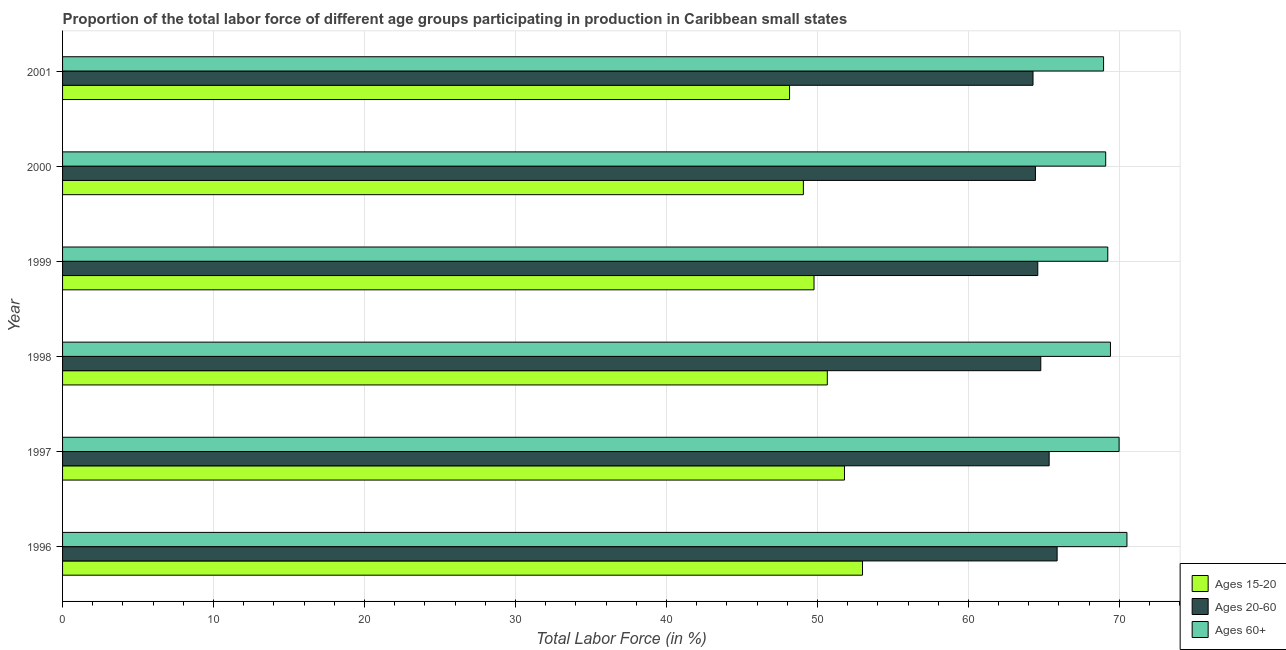How many groups of bars are there?
Give a very brief answer. 6. Are the number of bars per tick equal to the number of legend labels?
Your answer should be compact. Yes. How many bars are there on the 3rd tick from the top?
Your answer should be very brief. 3. What is the label of the 4th group of bars from the top?
Your answer should be very brief. 1998. What is the percentage of labor force within the age group 15-20 in 1997?
Make the answer very short. 51.79. Across all years, what is the maximum percentage of labor force within the age group 20-60?
Your response must be concise. 65.88. Across all years, what is the minimum percentage of labor force above age 60?
Keep it short and to the point. 68.95. In which year was the percentage of labor force within the age group 20-60 minimum?
Ensure brevity in your answer.  2001. What is the total percentage of labor force above age 60 in the graph?
Make the answer very short. 417.18. What is the difference between the percentage of labor force within the age group 15-20 in 1996 and that in 1999?
Your response must be concise. 3.21. What is the difference between the percentage of labor force within the age group 20-60 in 1996 and the percentage of labor force within the age group 15-20 in 1999?
Ensure brevity in your answer.  16.1. What is the average percentage of labor force above age 60 per year?
Offer a terse response. 69.53. In the year 1996, what is the difference between the percentage of labor force within the age group 20-60 and percentage of labor force within the age group 15-20?
Your answer should be very brief. 12.89. What is the ratio of the percentage of labor force above age 60 in 1998 to that in 2000?
Provide a succinct answer. 1. What is the difference between the highest and the second highest percentage of labor force above age 60?
Ensure brevity in your answer.  0.52. What is the difference between the highest and the lowest percentage of labor force within the age group 20-60?
Keep it short and to the point. 1.6. In how many years, is the percentage of labor force above age 60 greater than the average percentage of labor force above age 60 taken over all years?
Provide a short and direct response. 2. What does the 2nd bar from the top in 2000 represents?
Your answer should be very brief. Ages 20-60. What does the 2nd bar from the bottom in 1999 represents?
Offer a terse response. Ages 20-60. How many bars are there?
Provide a succinct answer. 18. How many years are there in the graph?
Your answer should be compact. 6. Are the values on the major ticks of X-axis written in scientific E-notation?
Your response must be concise. No. Where does the legend appear in the graph?
Your answer should be compact. Bottom right. What is the title of the graph?
Your response must be concise. Proportion of the total labor force of different age groups participating in production in Caribbean small states. What is the label or title of the Y-axis?
Provide a succinct answer. Year. What is the Total Labor Force (in %) of Ages 15-20 in 1996?
Provide a succinct answer. 52.99. What is the Total Labor Force (in %) of Ages 20-60 in 1996?
Provide a short and direct response. 65.88. What is the Total Labor Force (in %) in Ages 60+ in 1996?
Make the answer very short. 70.5. What is the Total Labor Force (in %) in Ages 15-20 in 1997?
Offer a terse response. 51.79. What is the Total Labor Force (in %) of Ages 20-60 in 1997?
Offer a terse response. 65.35. What is the Total Labor Force (in %) in Ages 60+ in 1997?
Ensure brevity in your answer.  69.98. What is the Total Labor Force (in %) in Ages 15-20 in 1998?
Keep it short and to the point. 50.66. What is the Total Labor Force (in %) of Ages 20-60 in 1998?
Ensure brevity in your answer.  64.79. What is the Total Labor Force (in %) in Ages 60+ in 1998?
Ensure brevity in your answer.  69.41. What is the Total Labor Force (in %) in Ages 15-20 in 1999?
Keep it short and to the point. 49.77. What is the Total Labor Force (in %) of Ages 20-60 in 1999?
Your answer should be compact. 64.6. What is the Total Labor Force (in %) in Ages 60+ in 1999?
Provide a short and direct response. 69.23. What is the Total Labor Force (in %) in Ages 15-20 in 2000?
Your response must be concise. 49.07. What is the Total Labor Force (in %) of Ages 20-60 in 2000?
Your response must be concise. 64.44. What is the Total Labor Force (in %) of Ages 60+ in 2000?
Offer a terse response. 69.1. What is the Total Labor Force (in %) of Ages 15-20 in 2001?
Ensure brevity in your answer.  48.16. What is the Total Labor Force (in %) of Ages 20-60 in 2001?
Provide a succinct answer. 64.28. What is the Total Labor Force (in %) in Ages 60+ in 2001?
Your answer should be very brief. 68.95. Across all years, what is the maximum Total Labor Force (in %) of Ages 15-20?
Your answer should be very brief. 52.99. Across all years, what is the maximum Total Labor Force (in %) in Ages 20-60?
Your response must be concise. 65.88. Across all years, what is the maximum Total Labor Force (in %) of Ages 60+?
Your response must be concise. 70.5. Across all years, what is the minimum Total Labor Force (in %) in Ages 15-20?
Your response must be concise. 48.16. Across all years, what is the minimum Total Labor Force (in %) of Ages 20-60?
Offer a terse response. 64.28. Across all years, what is the minimum Total Labor Force (in %) of Ages 60+?
Offer a terse response. 68.95. What is the total Total Labor Force (in %) in Ages 15-20 in the graph?
Give a very brief answer. 302.43. What is the total Total Labor Force (in %) of Ages 20-60 in the graph?
Provide a short and direct response. 389.34. What is the total Total Labor Force (in %) of Ages 60+ in the graph?
Keep it short and to the point. 417.18. What is the difference between the Total Labor Force (in %) in Ages 15-20 in 1996 and that in 1997?
Make the answer very short. 1.2. What is the difference between the Total Labor Force (in %) in Ages 20-60 in 1996 and that in 1997?
Make the answer very short. 0.53. What is the difference between the Total Labor Force (in %) in Ages 60+ in 1996 and that in 1997?
Offer a terse response. 0.52. What is the difference between the Total Labor Force (in %) of Ages 15-20 in 1996 and that in 1998?
Make the answer very short. 2.33. What is the difference between the Total Labor Force (in %) in Ages 20-60 in 1996 and that in 1998?
Keep it short and to the point. 1.08. What is the difference between the Total Labor Force (in %) of Ages 60+ in 1996 and that in 1998?
Offer a very short reply. 1.09. What is the difference between the Total Labor Force (in %) in Ages 15-20 in 1996 and that in 1999?
Give a very brief answer. 3.21. What is the difference between the Total Labor Force (in %) of Ages 20-60 in 1996 and that in 1999?
Your response must be concise. 1.28. What is the difference between the Total Labor Force (in %) in Ages 60+ in 1996 and that in 1999?
Give a very brief answer. 1.27. What is the difference between the Total Labor Force (in %) in Ages 15-20 in 1996 and that in 2000?
Provide a succinct answer. 3.92. What is the difference between the Total Labor Force (in %) in Ages 20-60 in 1996 and that in 2000?
Provide a short and direct response. 1.44. What is the difference between the Total Labor Force (in %) in Ages 60+ in 1996 and that in 2000?
Make the answer very short. 1.41. What is the difference between the Total Labor Force (in %) of Ages 15-20 in 1996 and that in 2001?
Give a very brief answer. 4.83. What is the difference between the Total Labor Force (in %) of Ages 20-60 in 1996 and that in 2001?
Ensure brevity in your answer.  1.6. What is the difference between the Total Labor Force (in %) in Ages 60+ in 1996 and that in 2001?
Offer a very short reply. 1.55. What is the difference between the Total Labor Force (in %) of Ages 15-20 in 1997 and that in 1998?
Offer a terse response. 1.14. What is the difference between the Total Labor Force (in %) of Ages 20-60 in 1997 and that in 1998?
Keep it short and to the point. 0.55. What is the difference between the Total Labor Force (in %) in Ages 60+ in 1997 and that in 1998?
Make the answer very short. 0.57. What is the difference between the Total Labor Force (in %) in Ages 15-20 in 1997 and that in 1999?
Ensure brevity in your answer.  2.02. What is the difference between the Total Labor Force (in %) of Ages 20-60 in 1997 and that in 1999?
Provide a short and direct response. 0.75. What is the difference between the Total Labor Force (in %) in Ages 60+ in 1997 and that in 1999?
Make the answer very short. 0.75. What is the difference between the Total Labor Force (in %) in Ages 15-20 in 1997 and that in 2000?
Make the answer very short. 2.72. What is the difference between the Total Labor Force (in %) in Ages 20-60 in 1997 and that in 2000?
Your response must be concise. 0.91. What is the difference between the Total Labor Force (in %) of Ages 60+ in 1997 and that in 2000?
Offer a very short reply. 0.89. What is the difference between the Total Labor Force (in %) in Ages 15-20 in 1997 and that in 2001?
Provide a short and direct response. 3.64. What is the difference between the Total Labor Force (in %) in Ages 20-60 in 1997 and that in 2001?
Provide a short and direct response. 1.07. What is the difference between the Total Labor Force (in %) of Ages 60+ in 1997 and that in 2001?
Your answer should be very brief. 1.03. What is the difference between the Total Labor Force (in %) of Ages 15-20 in 1998 and that in 1999?
Offer a terse response. 0.88. What is the difference between the Total Labor Force (in %) of Ages 20-60 in 1998 and that in 1999?
Your answer should be very brief. 0.2. What is the difference between the Total Labor Force (in %) of Ages 60+ in 1998 and that in 1999?
Your response must be concise. 0.18. What is the difference between the Total Labor Force (in %) of Ages 15-20 in 1998 and that in 2000?
Make the answer very short. 1.59. What is the difference between the Total Labor Force (in %) of Ages 20-60 in 1998 and that in 2000?
Give a very brief answer. 0.35. What is the difference between the Total Labor Force (in %) of Ages 60+ in 1998 and that in 2000?
Make the answer very short. 0.32. What is the difference between the Total Labor Force (in %) of Ages 15-20 in 1998 and that in 2001?
Your answer should be very brief. 2.5. What is the difference between the Total Labor Force (in %) of Ages 20-60 in 1998 and that in 2001?
Keep it short and to the point. 0.51. What is the difference between the Total Labor Force (in %) of Ages 60+ in 1998 and that in 2001?
Your answer should be very brief. 0.46. What is the difference between the Total Labor Force (in %) of Ages 15-20 in 1999 and that in 2000?
Your answer should be compact. 0.71. What is the difference between the Total Labor Force (in %) in Ages 20-60 in 1999 and that in 2000?
Your answer should be compact. 0.16. What is the difference between the Total Labor Force (in %) in Ages 60+ in 1999 and that in 2000?
Your answer should be very brief. 0.14. What is the difference between the Total Labor Force (in %) of Ages 15-20 in 1999 and that in 2001?
Your answer should be very brief. 1.62. What is the difference between the Total Labor Force (in %) in Ages 20-60 in 1999 and that in 2001?
Offer a very short reply. 0.32. What is the difference between the Total Labor Force (in %) of Ages 60+ in 1999 and that in 2001?
Your answer should be very brief. 0.28. What is the difference between the Total Labor Force (in %) of Ages 15-20 in 2000 and that in 2001?
Give a very brief answer. 0.91. What is the difference between the Total Labor Force (in %) in Ages 20-60 in 2000 and that in 2001?
Provide a succinct answer. 0.16. What is the difference between the Total Labor Force (in %) of Ages 60+ in 2000 and that in 2001?
Keep it short and to the point. 0.14. What is the difference between the Total Labor Force (in %) in Ages 15-20 in 1996 and the Total Labor Force (in %) in Ages 20-60 in 1997?
Your answer should be compact. -12.36. What is the difference between the Total Labor Force (in %) of Ages 15-20 in 1996 and the Total Labor Force (in %) of Ages 60+ in 1997?
Provide a succinct answer. -17. What is the difference between the Total Labor Force (in %) of Ages 20-60 in 1996 and the Total Labor Force (in %) of Ages 60+ in 1997?
Ensure brevity in your answer.  -4.11. What is the difference between the Total Labor Force (in %) of Ages 15-20 in 1996 and the Total Labor Force (in %) of Ages 20-60 in 1998?
Your answer should be compact. -11.81. What is the difference between the Total Labor Force (in %) of Ages 15-20 in 1996 and the Total Labor Force (in %) of Ages 60+ in 1998?
Offer a terse response. -16.42. What is the difference between the Total Labor Force (in %) of Ages 20-60 in 1996 and the Total Labor Force (in %) of Ages 60+ in 1998?
Give a very brief answer. -3.53. What is the difference between the Total Labor Force (in %) in Ages 15-20 in 1996 and the Total Labor Force (in %) in Ages 20-60 in 1999?
Your answer should be compact. -11.61. What is the difference between the Total Labor Force (in %) of Ages 15-20 in 1996 and the Total Labor Force (in %) of Ages 60+ in 1999?
Your answer should be compact. -16.25. What is the difference between the Total Labor Force (in %) in Ages 20-60 in 1996 and the Total Labor Force (in %) in Ages 60+ in 1999?
Give a very brief answer. -3.36. What is the difference between the Total Labor Force (in %) of Ages 15-20 in 1996 and the Total Labor Force (in %) of Ages 20-60 in 2000?
Offer a terse response. -11.45. What is the difference between the Total Labor Force (in %) of Ages 15-20 in 1996 and the Total Labor Force (in %) of Ages 60+ in 2000?
Offer a very short reply. -16.11. What is the difference between the Total Labor Force (in %) of Ages 20-60 in 1996 and the Total Labor Force (in %) of Ages 60+ in 2000?
Provide a short and direct response. -3.22. What is the difference between the Total Labor Force (in %) of Ages 15-20 in 1996 and the Total Labor Force (in %) of Ages 20-60 in 2001?
Offer a very short reply. -11.29. What is the difference between the Total Labor Force (in %) in Ages 15-20 in 1996 and the Total Labor Force (in %) in Ages 60+ in 2001?
Provide a succinct answer. -15.97. What is the difference between the Total Labor Force (in %) of Ages 20-60 in 1996 and the Total Labor Force (in %) of Ages 60+ in 2001?
Provide a succinct answer. -3.08. What is the difference between the Total Labor Force (in %) of Ages 15-20 in 1997 and the Total Labor Force (in %) of Ages 20-60 in 1998?
Your answer should be compact. -13. What is the difference between the Total Labor Force (in %) in Ages 15-20 in 1997 and the Total Labor Force (in %) in Ages 60+ in 1998?
Your answer should be compact. -17.62. What is the difference between the Total Labor Force (in %) in Ages 20-60 in 1997 and the Total Labor Force (in %) in Ages 60+ in 1998?
Give a very brief answer. -4.06. What is the difference between the Total Labor Force (in %) of Ages 15-20 in 1997 and the Total Labor Force (in %) of Ages 20-60 in 1999?
Give a very brief answer. -12.8. What is the difference between the Total Labor Force (in %) of Ages 15-20 in 1997 and the Total Labor Force (in %) of Ages 60+ in 1999?
Offer a terse response. -17.44. What is the difference between the Total Labor Force (in %) in Ages 20-60 in 1997 and the Total Labor Force (in %) in Ages 60+ in 1999?
Offer a very short reply. -3.88. What is the difference between the Total Labor Force (in %) in Ages 15-20 in 1997 and the Total Labor Force (in %) in Ages 20-60 in 2000?
Offer a terse response. -12.65. What is the difference between the Total Labor Force (in %) of Ages 15-20 in 1997 and the Total Labor Force (in %) of Ages 60+ in 2000?
Offer a very short reply. -17.3. What is the difference between the Total Labor Force (in %) of Ages 20-60 in 1997 and the Total Labor Force (in %) of Ages 60+ in 2000?
Your response must be concise. -3.75. What is the difference between the Total Labor Force (in %) in Ages 15-20 in 1997 and the Total Labor Force (in %) in Ages 20-60 in 2001?
Keep it short and to the point. -12.49. What is the difference between the Total Labor Force (in %) of Ages 15-20 in 1997 and the Total Labor Force (in %) of Ages 60+ in 2001?
Provide a succinct answer. -17.16. What is the difference between the Total Labor Force (in %) of Ages 20-60 in 1997 and the Total Labor Force (in %) of Ages 60+ in 2001?
Keep it short and to the point. -3.61. What is the difference between the Total Labor Force (in %) in Ages 15-20 in 1998 and the Total Labor Force (in %) in Ages 20-60 in 1999?
Offer a terse response. -13.94. What is the difference between the Total Labor Force (in %) in Ages 15-20 in 1998 and the Total Labor Force (in %) in Ages 60+ in 1999?
Provide a succinct answer. -18.58. What is the difference between the Total Labor Force (in %) in Ages 20-60 in 1998 and the Total Labor Force (in %) in Ages 60+ in 1999?
Your response must be concise. -4.44. What is the difference between the Total Labor Force (in %) in Ages 15-20 in 1998 and the Total Labor Force (in %) in Ages 20-60 in 2000?
Provide a succinct answer. -13.79. What is the difference between the Total Labor Force (in %) in Ages 15-20 in 1998 and the Total Labor Force (in %) in Ages 60+ in 2000?
Make the answer very short. -18.44. What is the difference between the Total Labor Force (in %) in Ages 20-60 in 1998 and the Total Labor Force (in %) in Ages 60+ in 2000?
Provide a short and direct response. -4.3. What is the difference between the Total Labor Force (in %) in Ages 15-20 in 1998 and the Total Labor Force (in %) in Ages 20-60 in 2001?
Ensure brevity in your answer.  -13.63. What is the difference between the Total Labor Force (in %) of Ages 15-20 in 1998 and the Total Labor Force (in %) of Ages 60+ in 2001?
Make the answer very short. -18.3. What is the difference between the Total Labor Force (in %) in Ages 20-60 in 1998 and the Total Labor Force (in %) in Ages 60+ in 2001?
Provide a succinct answer. -4.16. What is the difference between the Total Labor Force (in %) in Ages 15-20 in 1999 and the Total Labor Force (in %) in Ages 20-60 in 2000?
Offer a terse response. -14.67. What is the difference between the Total Labor Force (in %) in Ages 15-20 in 1999 and the Total Labor Force (in %) in Ages 60+ in 2000?
Provide a short and direct response. -19.32. What is the difference between the Total Labor Force (in %) in Ages 20-60 in 1999 and the Total Labor Force (in %) in Ages 60+ in 2000?
Your answer should be compact. -4.5. What is the difference between the Total Labor Force (in %) in Ages 15-20 in 1999 and the Total Labor Force (in %) in Ages 20-60 in 2001?
Your response must be concise. -14.51. What is the difference between the Total Labor Force (in %) in Ages 15-20 in 1999 and the Total Labor Force (in %) in Ages 60+ in 2001?
Provide a short and direct response. -19.18. What is the difference between the Total Labor Force (in %) in Ages 20-60 in 1999 and the Total Labor Force (in %) in Ages 60+ in 2001?
Offer a terse response. -4.36. What is the difference between the Total Labor Force (in %) of Ages 15-20 in 2000 and the Total Labor Force (in %) of Ages 20-60 in 2001?
Provide a short and direct response. -15.21. What is the difference between the Total Labor Force (in %) in Ages 15-20 in 2000 and the Total Labor Force (in %) in Ages 60+ in 2001?
Your response must be concise. -19.89. What is the difference between the Total Labor Force (in %) of Ages 20-60 in 2000 and the Total Labor Force (in %) of Ages 60+ in 2001?
Give a very brief answer. -4.51. What is the average Total Labor Force (in %) in Ages 15-20 per year?
Your answer should be compact. 50.41. What is the average Total Labor Force (in %) of Ages 20-60 per year?
Provide a short and direct response. 64.89. What is the average Total Labor Force (in %) in Ages 60+ per year?
Offer a very short reply. 69.53. In the year 1996, what is the difference between the Total Labor Force (in %) in Ages 15-20 and Total Labor Force (in %) in Ages 20-60?
Your answer should be very brief. -12.89. In the year 1996, what is the difference between the Total Labor Force (in %) of Ages 15-20 and Total Labor Force (in %) of Ages 60+?
Your answer should be compact. -17.51. In the year 1996, what is the difference between the Total Labor Force (in %) of Ages 20-60 and Total Labor Force (in %) of Ages 60+?
Keep it short and to the point. -4.62. In the year 1997, what is the difference between the Total Labor Force (in %) in Ages 15-20 and Total Labor Force (in %) in Ages 20-60?
Offer a terse response. -13.56. In the year 1997, what is the difference between the Total Labor Force (in %) in Ages 15-20 and Total Labor Force (in %) in Ages 60+?
Keep it short and to the point. -18.19. In the year 1997, what is the difference between the Total Labor Force (in %) of Ages 20-60 and Total Labor Force (in %) of Ages 60+?
Your answer should be compact. -4.63. In the year 1998, what is the difference between the Total Labor Force (in %) in Ages 15-20 and Total Labor Force (in %) in Ages 20-60?
Ensure brevity in your answer.  -14.14. In the year 1998, what is the difference between the Total Labor Force (in %) in Ages 15-20 and Total Labor Force (in %) in Ages 60+?
Your response must be concise. -18.76. In the year 1998, what is the difference between the Total Labor Force (in %) in Ages 20-60 and Total Labor Force (in %) in Ages 60+?
Provide a succinct answer. -4.62. In the year 1999, what is the difference between the Total Labor Force (in %) of Ages 15-20 and Total Labor Force (in %) of Ages 20-60?
Provide a succinct answer. -14.82. In the year 1999, what is the difference between the Total Labor Force (in %) of Ages 15-20 and Total Labor Force (in %) of Ages 60+?
Provide a succinct answer. -19.46. In the year 1999, what is the difference between the Total Labor Force (in %) in Ages 20-60 and Total Labor Force (in %) in Ages 60+?
Provide a succinct answer. -4.64. In the year 2000, what is the difference between the Total Labor Force (in %) of Ages 15-20 and Total Labor Force (in %) of Ages 20-60?
Ensure brevity in your answer.  -15.37. In the year 2000, what is the difference between the Total Labor Force (in %) of Ages 15-20 and Total Labor Force (in %) of Ages 60+?
Provide a short and direct response. -20.03. In the year 2000, what is the difference between the Total Labor Force (in %) in Ages 20-60 and Total Labor Force (in %) in Ages 60+?
Offer a terse response. -4.65. In the year 2001, what is the difference between the Total Labor Force (in %) in Ages 15-20 and Total Labor Force (in %) in Ages 20-60?
Offer a terse response. -16.13. In the year 2001, what is the difference between the Total Labor Force (in %) of Ages 15-20 and Total Labor Force (in %) of Ages 60+?
Your answer should be very brief. -20.8. In the year 2001, what is the difference between the Total Labor Force (in %) of Ages 20-60 and Total Labor Force (in %) of Ages 60+?
Offer a terse response. -4.67. What is the ratio of the Total Labor Force (in %) of Ages 15-20 in 1996 to that in 1997?
Your response must be concise. 1.02. What is the ratio of the Total Labor Force (in %) in Ages 20-60 in 1996 to that in 1997?
Provide a succinct answer. 1.01. What is the ratio of the Total Labor Force (in %) in Ages 60+ in 1996 to that in 1997?
Keep it short and to the point. 1.01. What is the ratio of the Total Labor Force (in %) in Ages 15-20 in 1996 to that in 1998?
Keep it short and to the point. 1.05. What is the ratio of the Total Labor Force (in %) of Ages 20-60 in 1996 to that in 1998?
Give a very brief answer. 1.02. What is the ratio of the Total Labor Force (in %) of Ages 60+ in 1996 to that in 1998?
Offer a terse response. 1.02. What is the ratio of the Total Labor Force (in %) of Ages 15-20 in 1996 to that in 1999?
Your answer should be very brief. 1.06. What is the ratio of the Total Labor Force (in %) in Ages 20-60 in 1996 to that in 1999?
Your answer should be compact. 1.02. What is the ratio of the Total Labor Force (in %) of Ages 60+ in 1996 to that in 1999?
Ensure brevity in your answer.  1.02. What is the ratio of the Total Labor Force (in %) in Ages 15-20 in 1996 to that in 2000?
Make the answer very short. 1.08. What is the ratio of the Total Labor Force (in %) in Ages 20-60 in 1996 to that in 2000?
Offer a very short reply. 1.02. What is the ratio of the Total Labor Force (in %) in Ages 60+ in 1996 to that in 2000?
Provide a short and direct response. 1.02. What is the ratio of the Total Labor Force (in %) in Ages 15-20 in 1996 to that in 2001?
Ensure brevity in your answer.  1.1. What is the ratio of the Total Labor Force (in %) in Ages 20-60 in 1996 to that in 2001?
Give a very brief answer. 1.02. What is the ratio of the Total Labor Force (in %) of Ages 60+ in 1996 to that in 2001?
Make the answer very short. 1.02. What is the ratio of the Total Labor Force (in %) in Ages 15-20 in 1997 to that in 1998?
Provide a succinct answer. 1.02. What is the ratio of the Total Labor Force (in %) in Ages 20-60 in 1997 to that in 1998?
Offer a very short reply. 1.01. What is the ratio of the Total Labor Force (in %) of Ages 60+ in 1997 to that in 1998?
Your response must be concise. 1.01. What is the ratio of the Total Labor Force (in %) of Ages 15-20 in 1997 to that in 1999?
Make the answer very short. 1.04. What is the ratio of the Total Labor Force (in %) of Ages 20-60 in 1997 to that in 1999?
Provide a short and direct response. 1.01. What is the ratio of the Total Labor Force (in %) of Ages 60+ in 1997 to that in 1999?
Give a very brief answer. 1.01. What is the ratio of the Total Labor Force (in %) of Ages 15-20 in 1997 to that in 2000?
Provide a short and direct response. 1.06. What is the ratio of the Total Labor Force (in %) in Ages 20-60 in 1997 to that in 2000?
Ensure brevity in your answer.  1.01. What is the ratio of the Total Labor Force (in %) in Ages 60+ in 1997 to that in 2000?
Offer a terse response. 1.01. What is the ratio of the Total Labor Force (in %) of Ages 15-20 in 1997 to that in 2001?
Offer a terse response. 1.08. What is the ratio of the Total Labor Force (in %) in Ages 20-60 in 1997 to that in 2001?
Provide a short and direct response. 1.02. What is the ratio of the Total Labor Force (in %) in Ages 60+ in 1997 to that in 2001?
Offer a very short reply. 1.01. What is the ratio of the Total Labor Force (in %) in Ages 15-20 in 1998 to that in 1999?
Offer a very short reply. 1.02. What is the ratio of the Total Labor Force (in %) of Ages 20-60 in 1998 to that in 1999?
Ensure brevity in your answer.  1. What is the ratio of the Total Labor Force (in %) in Ages 60+ in 1998 to that in 1999?
Provide a short and direct response. 1. What is the ratio of the Total Labor Force (in %) of Ages 15-20 in 1998 to that in 2000?
Ensure brevity in your answer.  1.03. What is the ratio of the Total Labor Force (in %) of Ages 20-60 in 1998 to that in 2000?
Your response must be concise. 1.01. What is the ratio of the Total Labor Force (in %) in Ages 15-20 in 1998 to that in 2001?
Keep it short and to the point. 1.05. What is the ratio of the Total Labor Force (in %) of Ages 60+ in 1998 to that in 2001?
Your response must be concise. 1.01. What is the ratio of the Total Labor Force (in %) of Ages 15-20 in 1999 to that in 2000?
Your response must be concise. 1.01. What is the ratio of the Total Labor Force (in %) of Ages 20-60 in 1999 to that in 2000?
Offer a very short reply. 1. What is the ratio of the Total Labor Force (in %) in Ages 15-20 in 1999 to that in 2001?
Ensure brevity in your answer.  1.03. What is the ratio of the Total Labor Force (in %) of Ages 20-60 in 1999 to that in 2001?
Provide a short and direct response. 1. What is the ratio of the Total Labor Force (in %) in Ages 60+ in 1999 to that in 2001?
Make the answer very short. 1. What is the ratio of the Total Labor Force (in %) in Ages 20-60 in 2000 to that in 2001?
Provide a succinct answer. 1. What is the ratio of the Total Labor Force (in %) in Ages 60+ in 2000 to that in 2001?
Ensure brevity in your answer.  1. What is the difference between the highest and the second highest Total Labor Force (in %) in Ages 15-20?
Your answer should be very brief. 1.2. What is the difference between the highest and the second highest Total Labor Force (in %) of Ages 20-60?
Keep it short and to the point. 0.53. What is the difference between the highest and the second highest Total Labor Force (in %) in Ages 60+?
Offer a terse response. 0.52. What is the difference between the highest and the lowest Total Labor Force (in %) of Ages 15-20?
Provide a succinct answer. 4.83. What is the difference between the highest and the lowest Total Labor Force (in %) in Ages 20-60?
Give a very brief answer. 1.6. What is the difference between the highest and the lowest Total Labor Force (in %) in Ages 60+?
Offer a very short reply. 1.55. 